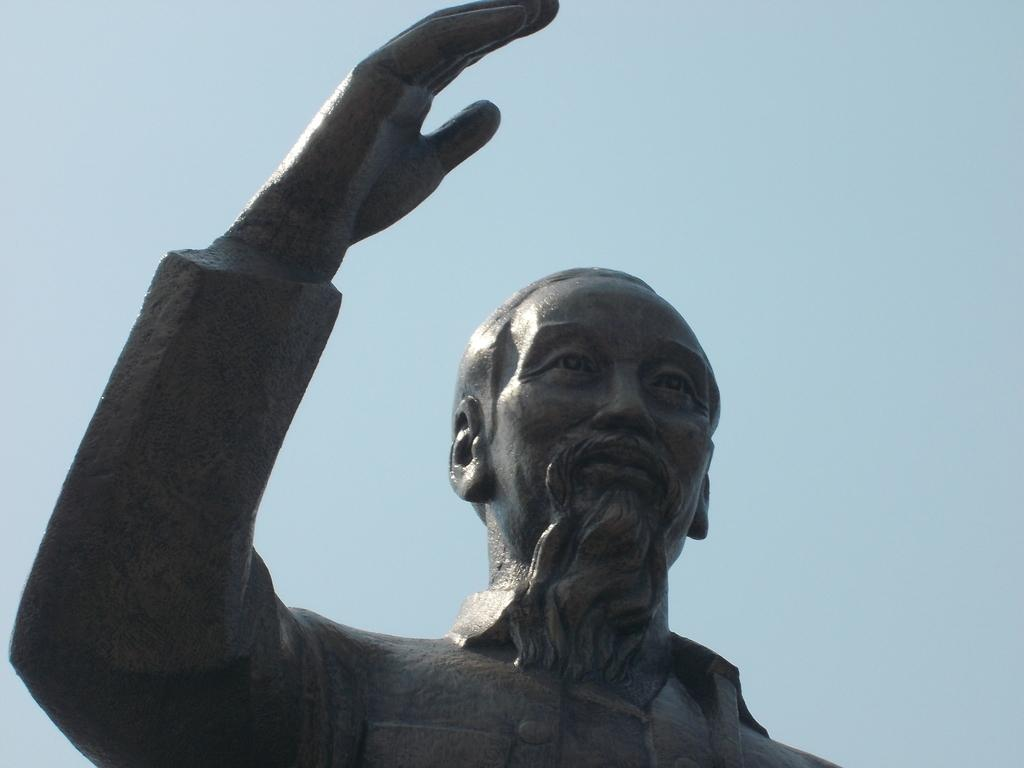What is the main subject of the image? There is a sculpture in the image. Can you describe the describe the appearance of the sculpture? The sculpture is black in color and is of a man. What color can be seen in the background of the image? There is a blue color in the background of the image. What type of shirt is the brother wearing in the image? There is no brother or shirt present in the image; it features a black sculpture of a man against a blue background. 